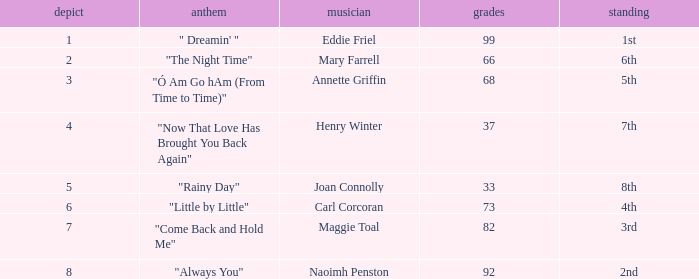When ranked 7th and having a draw under 4 points, what is the typical point total? None. 